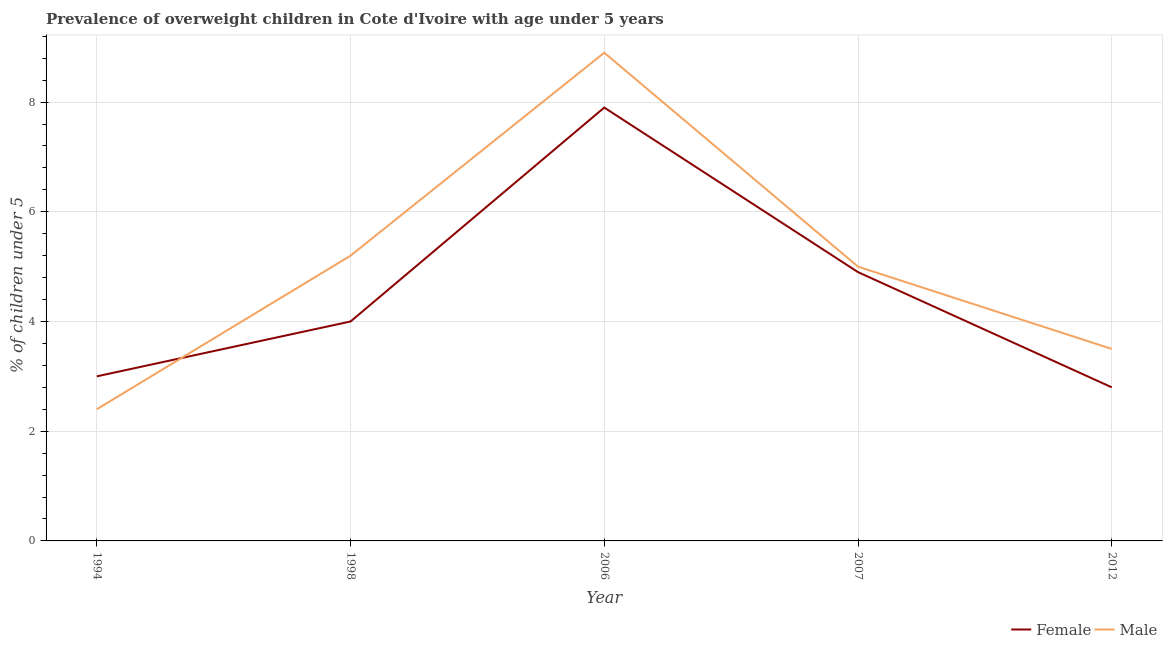How many different coloured lines are there?
Give a very brief answer. 2. What is the percentage of obese male children in 1998?
Make the answer very short. 5.2. Across all years, what is the maximum percentage of obese male children?
Provide a short and direct response. 8.9. Across all years, what is the minimum percentage of obese female children?
Provide a short and direct response. 2.8. In which year was the percentage of obese male children minimum?
Your answer should be very brief. 1994. What is the total percentage of obese male children in the graph?
Offer a very short reply. 25. What is the difference between the percentage of obese female children in 1998 and that in 2012?
Your answer should be compact. 1.2. What is the difference between the percentage of obese female children in 2006 and the percentage of obese male children in 1998?
Your response must be concise. 2.7. What is the average percentage of obese female children per year?
Make the answer very short. 4.52. In the year 1994, what is the difference between the percentage of obese female children and percentage of obese male children?
Keep it short and to the point. 0.6. In how many years, is the percentage of obese male children greater than 7.6 %?
Ensure brevity in your answer.  1. What is the ratio of the percentage of obese female children in 1994 to that in 2006?
Offer a terse response. 0.38. What is the difference between the highest and the second highest percentage of obese female children?
Offer a terse response. 3. What is the difference between the highest and the lowest percentage of obese male children?
Offer a very short reply. 6.5. Does the percentage of obese female children monotonically increase over the years?
Your response must be concise. No. Is the percentage of obese male children strictly greater than the percentage of obese female children over the years?
Provide a succinct answer. No. How many lines are there?
Make the answer very short. 2. How many years are there in the graph?
Offer a terse response. 5. Are the values on the major ticks of Y-axis written in scientific E-notation?
Provide a succinct answer. No. Does the graph contain grids?
Offer a terse response. Yes. How many legend labels are there?
Your answer should be very brief. 2. How are the legend labels stacked?
Your response must be concise. Horizontal. What is the title of the graph?
Give a very brief answer. Prevalence of overweight children in Cote d'Ivoire with age under 5 years. Does "Net National savings" appear as one of the legend labels in the graph?
Make the answer very short. No. What is the label or title of the X-axis?
Offer a very short reply. Year. What is the label or title of the Y-axis?
Keep it short and to the point.  % of children under 5. What is the  % of children under 5 of Female in 1994?
Keep it short and to the point. 3. What is the  % of children under 5 in Male in 1994?
Your response must be concise. 2.4. What is the  % of children under 5 of Female in 1998?
Provide a succinct answer. 4. What is the  % of children under 5 in Male in 1998?
Your response must be concise. 5.2. What is the  % of children under 5 of Female in 2006?
Ensure brevity in your answer.  7.9. What is the  % of children under 5 in Male in 2006?
Provide a short and direct response. 8.9. What is the  % of children under 5 in Female in 2007?
Provide a short and direct response. 4.9. What is the  % of children under 5 of Female in 2012?
Your answer should be very brief. 2.8. What is the  % of children under 5 in Male in 2012?
Provide a succinct answer. 3.5. Across all years, what is the maximum  % of children under 5 in Female?
Ensure brevity in your answer.  7.9. Across all years, what is the maximum  % of children under 5 in Male?
Your answer should be compact. 8.9. Across all years, what is the minimum  % of children under 5 of Female?
Give a very brief answer. 2.8. Across all years, what is the minimum  % of children under 5 of Male?
Ensure brevity in your answer.  2.4. What is the total  % of children under 5 in Female in the graph?
Offer a terse response. 22.6. What is the total  % of children under 5 of Male in the graph?
Your answer should be compact. 25. What is the difference between the  % of children under 5 in Female in 1994 and that in 1998?
Give a very brief answer. -1. What is the difference between the  % of children under 5 in Male in 1994 and that in 2006?
Offer a terse response. -6.5. What is the difference between the  % of children under 5 of Male in 1994 and that in 2012?
Your answer should be very brief. -1.1. What is the difference between the  % of children under 5 in Male in 1998 and that in 2007?
Offer a terse response. 0.2. What is the difference between the  % of children under 5 of Male in 2006 and that in 2007?
Your response must be concise. 3.9. What is the difference between the  % of children under 5 in Female in 2007 and that in 2012?
Ensure brevity in your answer.  2.1. What is the difference between the  % of children under 5 of Female in 1994 and the  % of children under 5 of Male in 1998?
Your answer should be compact. -2.2. What is the difference between the  % of children under 5 in Female in 1994 and the  % of children under 5 in Male in 2006?
Give a very brief answer. -5.9. What is the difference between the  % of children under 5 of Female in 1998 and the  % of children under 5 of Male in 2006?
Offer a terse response. -4.9. What is the difference between the  % of children under 5 in Female in 2006 and the  % of children under 5 in Male in 2007?
Make the answer very short. 2.9. What is the difference between the  % of children under 5 in Female in 2006 and the  % of children under 5 in Male in 2012?
Make the answer very short. 4.4. What is the difference between the  % of children under 5 of Female in 2007 and the  % of children under 5 of Male in 2012?
Provide a short and direct response. 1.4. What is the average  % of children under 5 of Female per year?
Your answer should be compact. 4.52. What is the average  % of children under 5 in Male per year?
Your response must be concise. 5. In the year 2006, what is the difference between the  % of children under 5 in Female and  % of children under 5 in Male?
Make the answer very short. -1. In the year 2012, what is the difference between the  % of children under 5 of Female and  % of children under 5 of Male?
Your response must be concise. -0.7. What is the ratio of the  % of children under 5 in Female in 1994 to that in 1998?
Your response must be concise. 0.75. What is the ratio of the  % of children under 5 in Male in 1994 to that in 1998?
Give a very brief answer. 0.46. What is the ratio of the  % of children under 5 in Female in 1994 to that in 2006?
Your answer should be compact. 0.38. What is the ratio of the  % of children under 5 of Male in 1994 to that in 2006?
Make the answer very short. 0.27. What is the ratio of the  % of children under 5 of Female in 1994 to that in 2007?
Keep it short and to the point. 0.61. What is the ratio of the  % of children under 5 of Male in 1994 to that in 2007?
Give a very brief answer. 0.48. What is the ratio of the  % of children under 5 of Female in 1994 to that in 2012?
Provide a succinct answer. 1.07. What is the ratio of the  % of children under 5 in Male in 1994 to that in 2012?
Offer a terse response. 0.69. What is the ratio of the  % of children under 5 in Female in 1998 to that in 2006?
Keep it short and to the point. 0.51. What is the ratio of the  % of children under 5 in Male in 1998 to that in 2006?
Give a very brief answer. 0.58. What is the ratio of the  % of children under 5 in Female in 1998 to that in 2007?
Provide a succinct answer. 0.82. What is the ratio of the  % of children under 5 in Male in 1998 to that in 2007?
Your answer should be very brief. 1.04. What is the ratio of the  % of children under 5 of Female in 1998 to that in 2012?
Ensure brevity in your answer.  1.43. What is the ratio of the  % of children under 5 of Male in 1998 to that in 2012?
Your answer should be compact. 1.49. What is the ratio of the  % of children under 5 of Female in 2006 to that in 2007?
Your answer should be very brief. 1.61. What is the ratio of the  % of children under 5 in Male in 2006 to that in 2007?
Offer a very short reply. 1.78. What is the ratio of the  % of children under 5 of Female in 2006 to that in 2012?
Make the answer very short. 2.82. What is the ratio of the  % of children under 5 of Male in 2006 to that in 2012?
Your response must be concise. 2.54. What is the ratio of the  % of children under 5 of Male in 2007 to that in 2012?
Ensure brevity in your answer.  1.43. What is the difference between the highest and the lowest  % of children under 5 of Male?
Provide a succinct answer. 6.5. 